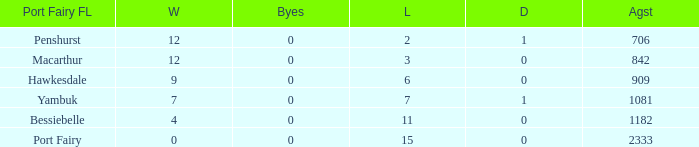How many wins for Port Fairy and against more than 2333? None. 